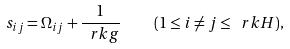<formula> <loc_0><loc_0><loc_500><loc_500>s _ { i j } = \Omega _ { i j } + \frac { 1 } { \ r k g } \quad ( 1 \leq i \neq j \leq \ r k H ) ,</formula> 